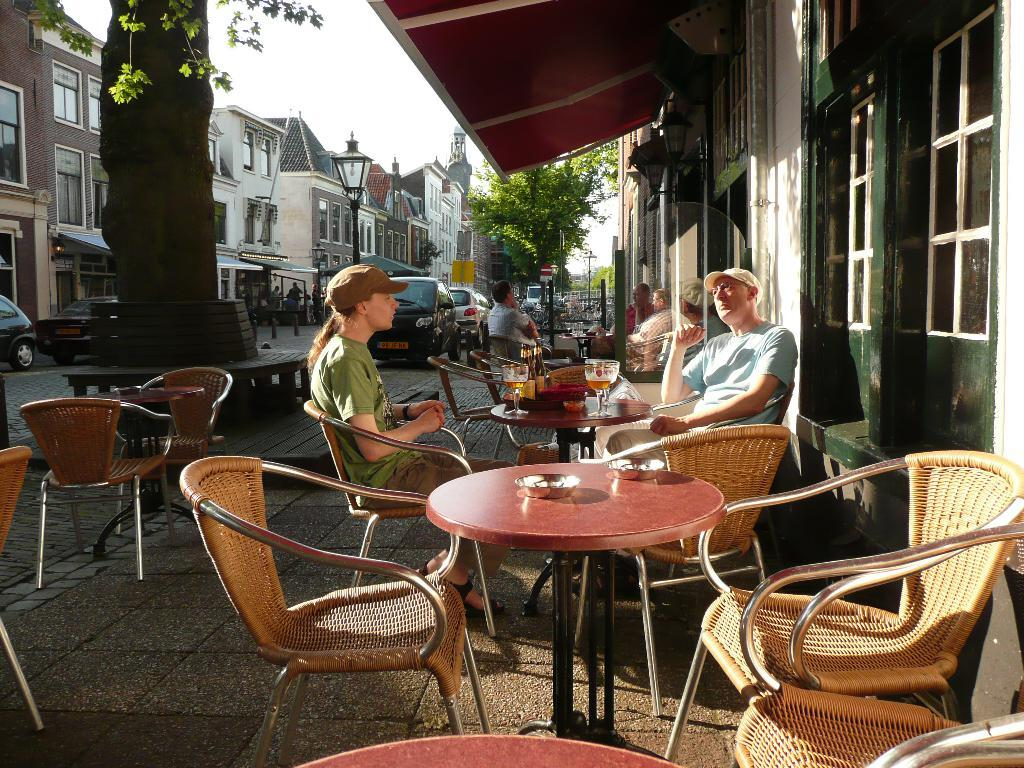How many people are sitting on the chair in the image? There is a group of persons sitting on a chair in the image. What can be seen on the left side of the image? There are buildings, cars, trees, and persons walking on the floor on the left side of the image. Can you tell me how many times the maid sneezes in the image? There is no maid present in the image, and therefore no sneezing can be observed. 